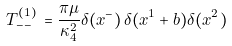<formula> <loc_0><loc_0><loc_500><loc_500>T ^ { ( 1 ) } _ { - - } \, = \frac { \pi \mu } { \kappa _ { 4 } ^ { 2 } } \delta ( x ^ { - } ) \, \delta ( x ^ { 1 } + b ) \delta ( x ^ { 2 } )</formula> 